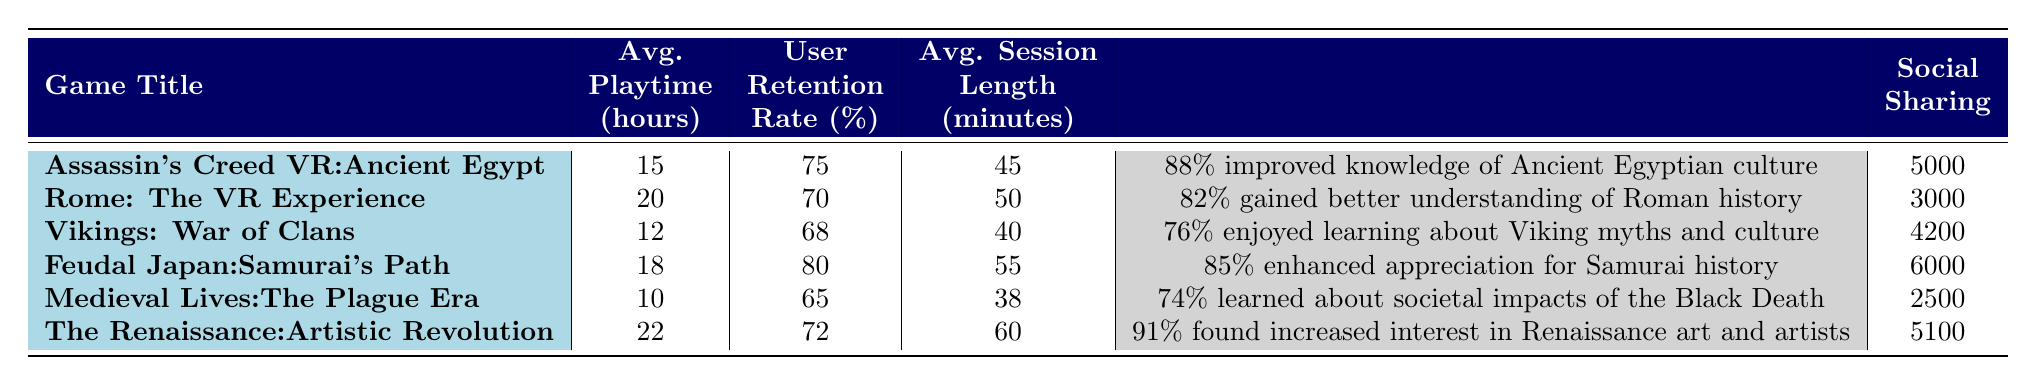What is the average playtime for "Feudal Japan: Samurai's Path"? The table shows that the average playtime for "Feudal Japan: Samurai's Path" is recorded as 18 hours.
Answer: 18 hours Which game has the highest user retention rate? By comparing the user retention rates listed in the table, "Feudal Japan: Samurai's Path" has the highest retention rate at 80%.
Answer: 80% What is the average session length for "Vikings: War of Clans"? The average session length for "Vikings: War of Clans" is indicated as 40 minutes in the table.
Answer: 40 minutes How many total social shares were recorded for all the games? To find the total social shares, we sum the values: 5000 + 3000 + 4200 + 6000 + 2500 + 5100 = 25800.
Answer: 25800 What percentage of players in "The Renaissance: Artistic Revolution" reported an increased interest in Renaissance art? According to the table, 91% of players reported an increased interest in Renaissance art and artists in that game.
Answer: 91% Is the average playtime for "Rome: The VR Experience" longer than that for "Medieval Lives: The Plague Era"? The average playtime for "Rome: The VR Experience" is 20 hours, while for "Medieval Lives: The Plague Era" it is 10 hours. Thus, 20 is greater than 10, confirming the statement is true.
Answer: Yes What is the difference in average session length between "Assassin's Creed VR: Ancient Egypt" and "The Renaissance: Artistic Revolution"? The average session length for "Assassin's Creed VR: Ancient Egypt" is 45 minutes, and for "The Renaissance: Artistic Revolution" it is 60 minutes. The difference is 60 - 45 = 15 minutes.
Answer: 15 minutes Based on the data, which game had the least amount of social sharing? Examining the social sharing values, "Medieval Lives: The Plague Era" had the least social shares with a total of 2500.
Answer: 2500 What is the average user retention rate across all games listed? The retention rates are: 75, 70, 68, 80, 65, and 72. To find the average, we sum them up: 75 + 70 + 68 + 80 + 65 + 72 = 430, and then divide by 6. The average user retention rate is 430 / 6 ≈ 71.67%.
Answer: Approximately 71.67% For how many games did more than 80% of players report improved learning outcomes? Reviewing the learning outcomes, "Assassin's Creed VR: Ancient Egypt" (88%), "Feudal Japan: Samurai's Path" (85%), and "The Renaissance: Artistic Revolution" (91%) show results over 80%. Thus, there are three such games.
Answer: 3 